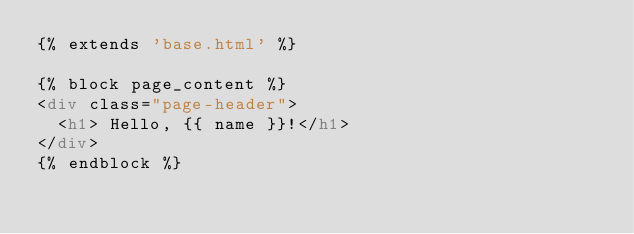<code> <loc_0><loc_0><loc_500><loc_500><_HTML_>{% extends 'base.html' %}

{% block page_content %}
<div class="page-header">
  <h1> Hello, {{ name }}!</h1>
</div>
{% endblock %}
</code> 